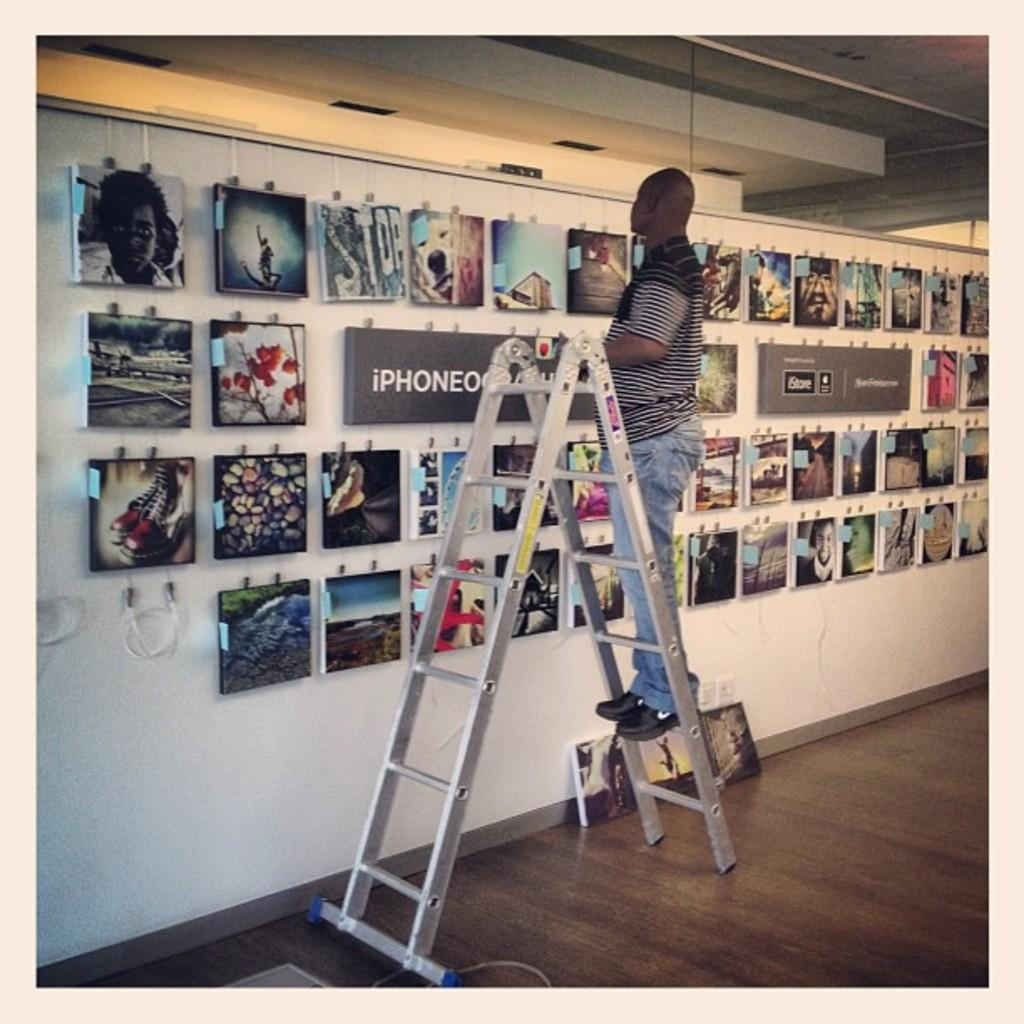<image>
Provide a brief description of the given image. A man standing on a ladder in front of an iPhone sign. 